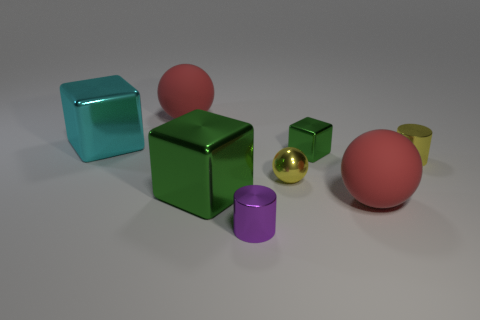Subtract all red spheres. How many spheres are left? 1 Subtract all purple blocks. How many red spheres are left? 2 Add 1 tiny blue rubber spheres. How many objects exist? 9 Subtract all spheres. How many objects are left? 5 Subtract all gray spheres. Subtract all red blocks. How many spheres are left? 3 Subtract all large red matte balls. Subtract all yellow shiny cylinders. How many objects are left? 5 Add 3 yellow things. How many yellow things are left? 5 Add 7 blue matte spheres. How many blue matte spheres exist? 7 Subtract 0 blue cubes. How many objects are left? 8 